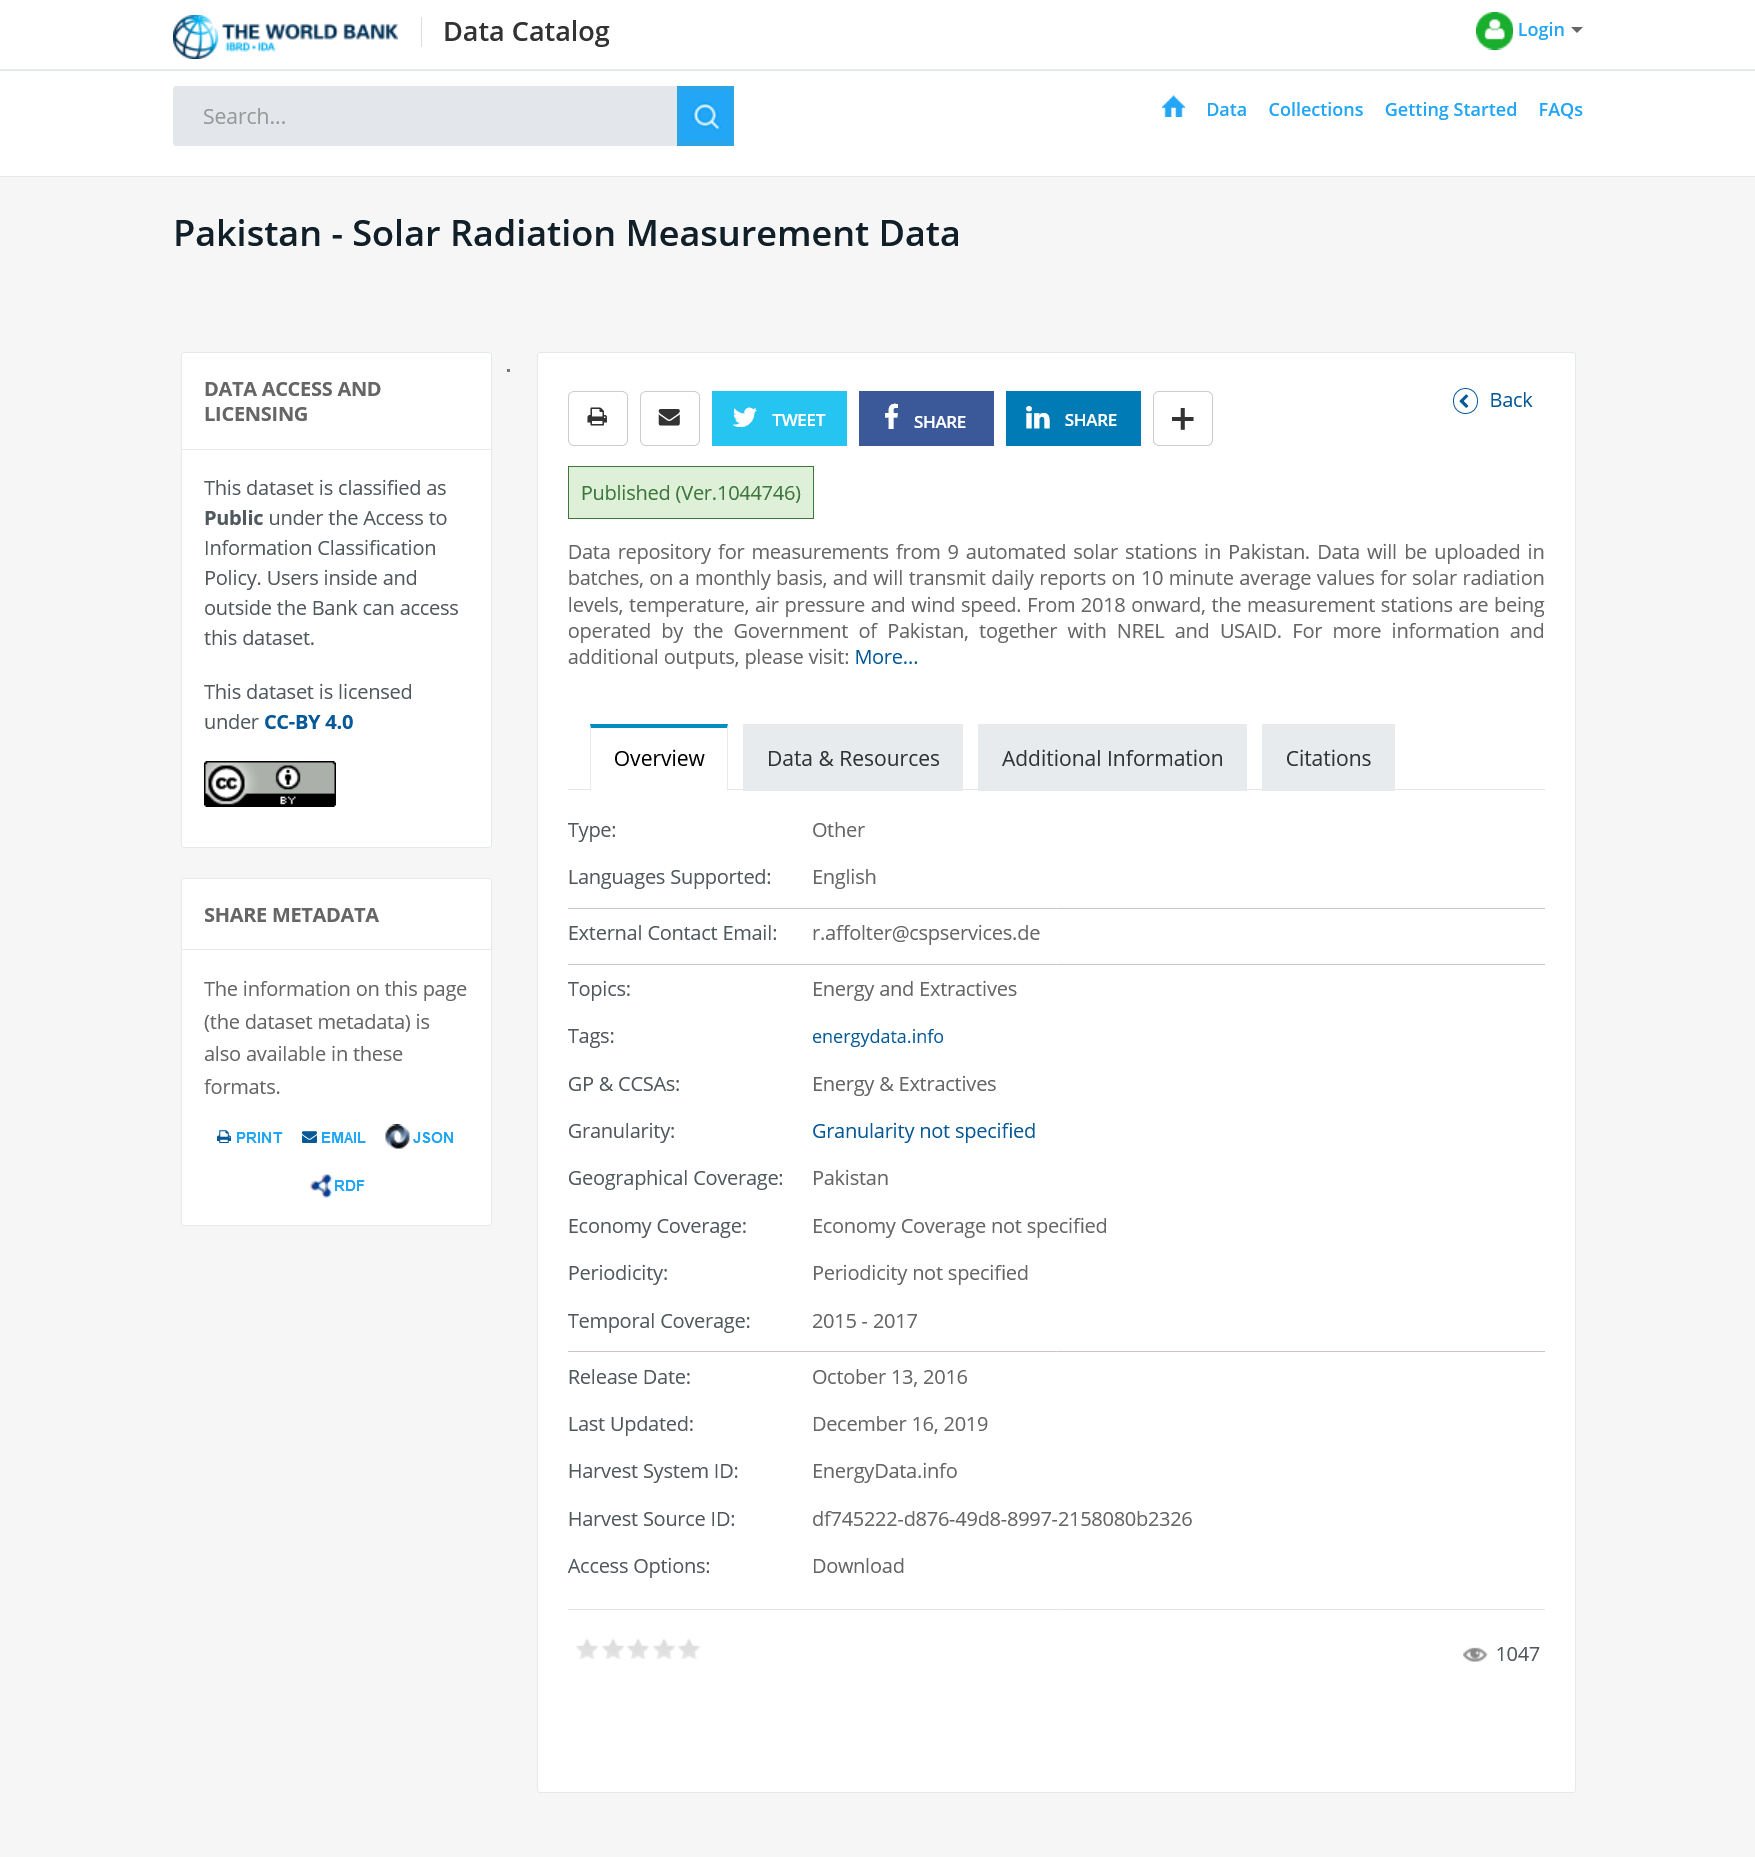Specify some key components in this picture. The Solar Radiation Measurement Data will be uploaded on a monthly basis. According to the Data Access and Agreement, this dataset is classified as public. The measurement stations are operated by the Government of Pakistan, NREL, and USAID. 